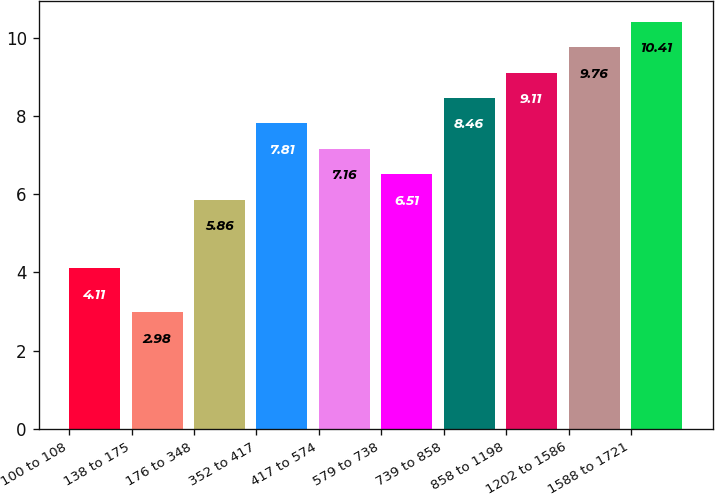Convert chart to OTSL. <chart><loc_0><loc_0><loc_500><loc_500><bar_chart><fcel>100 to 108<fcel>138 to 175<fcel>176 to 348<fcel>352 to 417<fcel>417 to 574<fcel>579 to 738<fcel>739 to 858<fcel>858 to 1198<fcel>1202 to 1586<fcel>1588 to 1721<nl><fcel>4.11<fcel>2.98<fcel>5.86<fcel>7.81<fcel>7.16<fcel>6.51<fcel>8.46<fcel>9.11<fcel>9.76<fcel>10.41<nl></chart> 